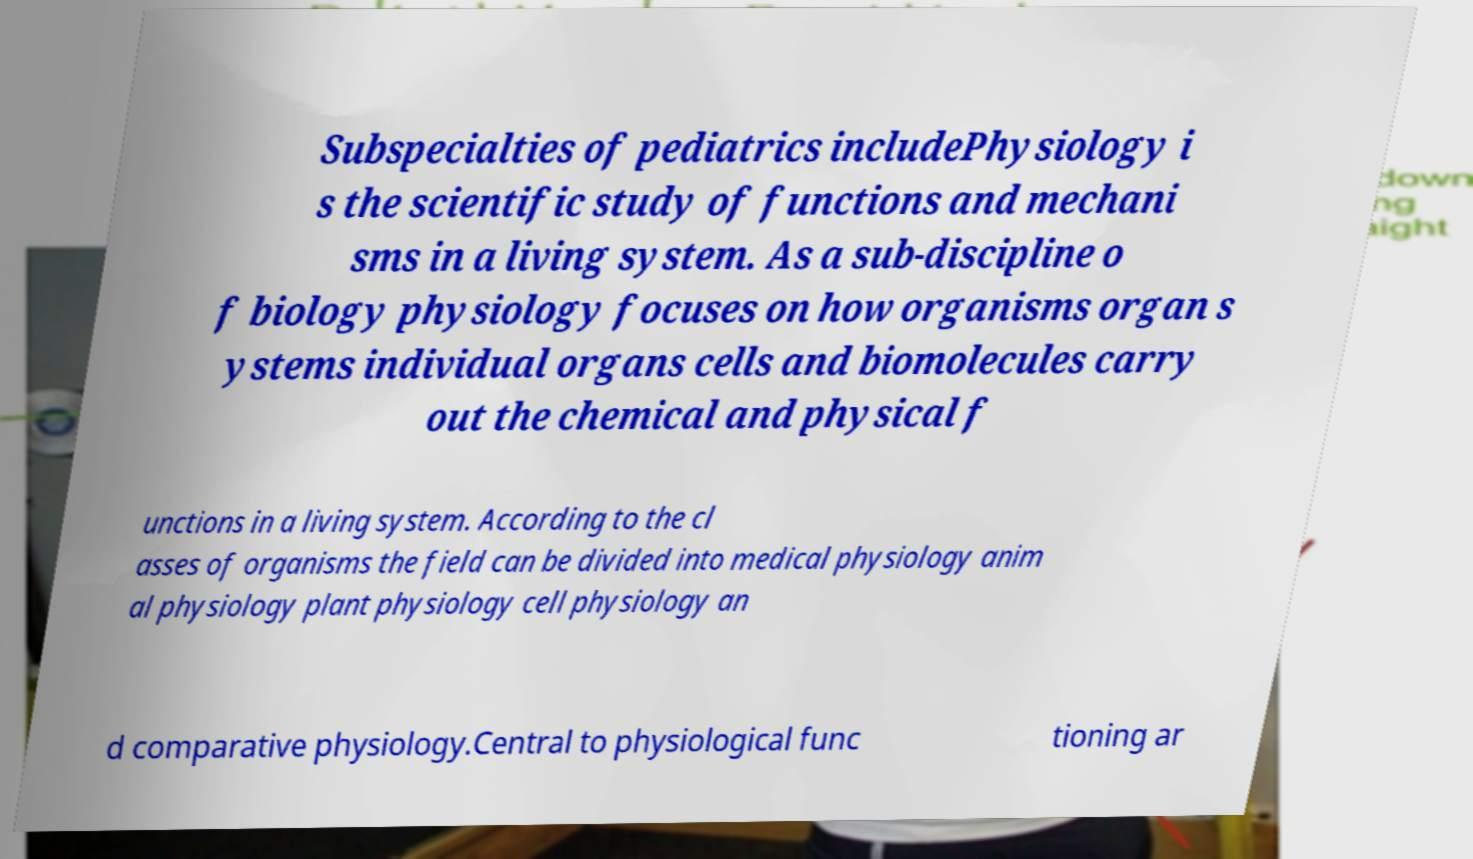Please read and relay the text visible in this image. What does it say? Subspecialties of pediatrics includePhysiology i s the scientific study of functions and mechani sms in a living system. As a sub-discipline o f biology physiology focuses on how organisms organ s ystems individual organs cells and biomolecules carry out the chemical and physical f unctions in a living system. According to the cl asses of organisms the field can be divided into medical physiology anim al physiology plant physiology cell physiology an d comparative physiology.Central to physiological func tioning ar 